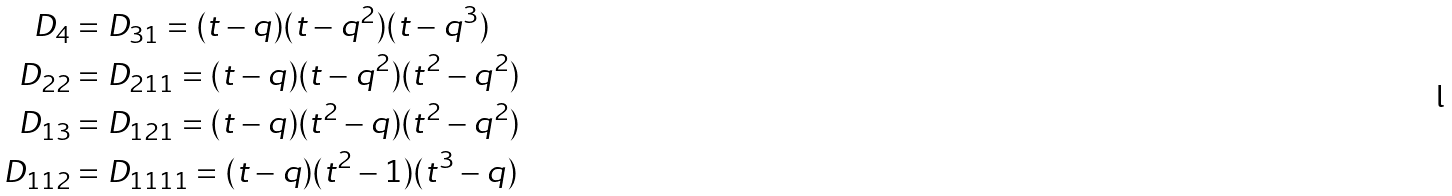Convert formula to latex. <formula><loc_0><loc_0><loc_500><loc_500>D _ { 4 } & = D _ { 3 1 } = ( t - q ) ( t - q ^ { 2 } ) ( t - q ^ { 3 } ) \\ D _ { 2 2 } & = D _ { 2 1 1 } = ( t - q ) ( t - q ^ { 2 } ) ( t ^ { 2 } - q ^ { 2 } ) \\ D _ { 1 3 } & = D _ { 1 2 1 } = ( t - q ) ( t ^ { 2 } - q ) ( t ^ { 2 } - q ^ { 2 } ) \\ D _ { 1 1 2 } & = D _ { 1 1 1 1 } = ( t - q ) ( t ^ { 2 } - 1 ) ( t ^ { 3 } - q )</formula> 